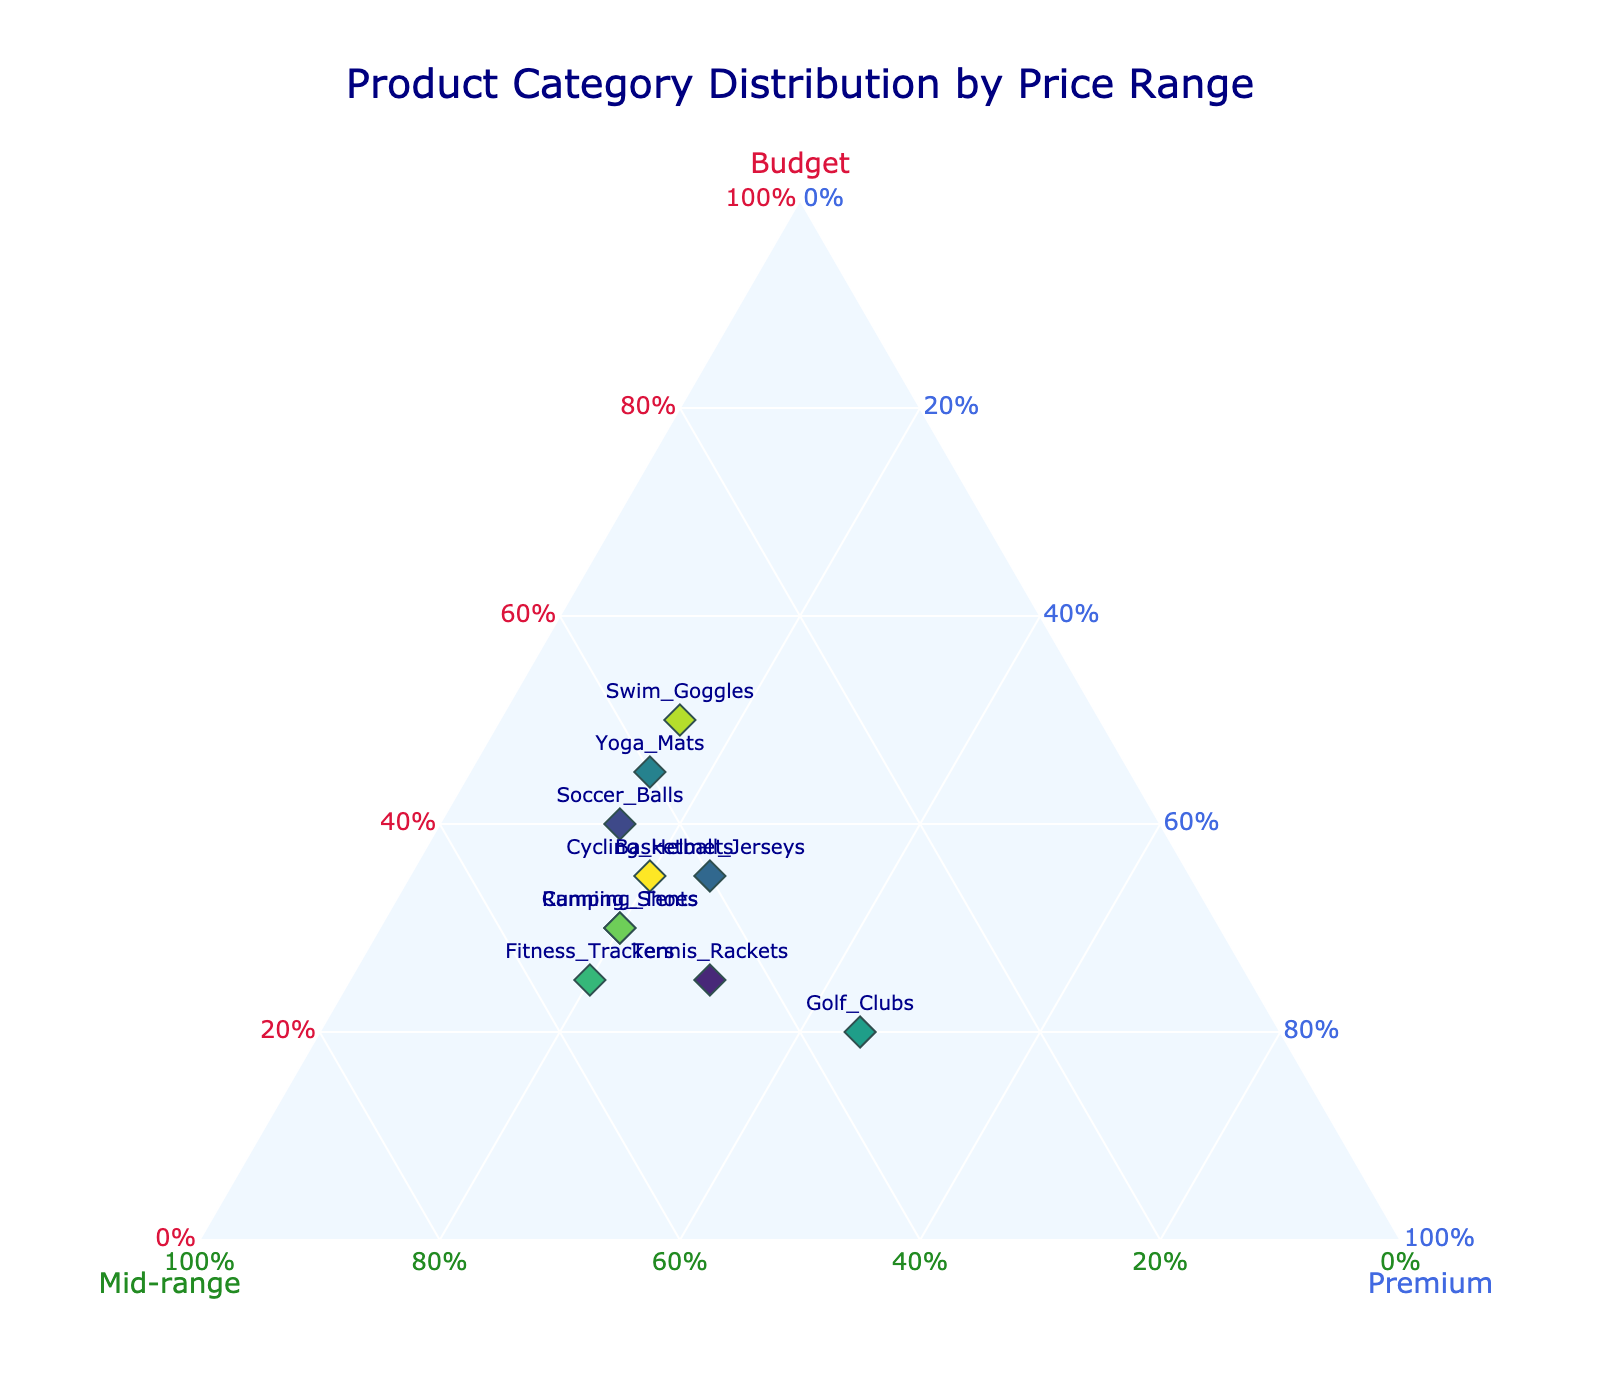What are the three price range categories shown in the plot? The three price range categories shown in the plot are labeled on each axis. They are 'Budget', 'Mid-range', and 'Premium'.
Answer: Budget, Mid-range, Premium How many product categories are displayed in the plot? The plot shows the labels of the product categories as text annotations on the markers. Counting these labels will give the number of product categories.
Answer: 10 Which product category has the highest percentage of Budget products? Locate the marker closest to the 'Budget' axis vertex, which represents the highest percentage of Budget products. The text annotation near this point will indicate the product category.
Answer: Swim Goggles What is the distribution percentage for Budget, Mid-range, and Premium products in Running Shoes? Hover over the marker labeled 'Running Shoes' to see the distribution percentages in the hover text.
Answer: Budget: 30%, Mid-range: 50%, Premium: 20% Compare the percentage of Premium products between Golf Clubs and Soccer Balls. Find the markers corresponding to Golf Clubs and Soccer Balls. Hover over these markers to see the percentage of Premium products in the hover text. Compare the two percentages.
Answer: Golf Clubs: 45%, Soccer Balls: 15% Which product category is evenly balanced between Budget and Mid-range products? Locate the marker closest to the midpoint of the line between the 'Budget' and 'Mid-range' vertices. The text annotation will indicate the product category.
Answer: Basketball Jerseys Calculate the average percentage of Mid-range products among all product categories. Sum the Mid-range percentages of all product categories and divide by the number of categories: (50 + 45 + 45 + 40 + 40 + 35 + 55 + 50 + 35 + 45) / 10 = 44%
Answer: 44% Which product category is closest to having an equal distribution across Budget, Mid-range, and Premium products? Find the marker closest to the center of the ternary plot. Use the text annotation near this point to identify the product category.
Answer: Tennis Rackets Determine the differences in the percentage of Budget products between Yoga Mats and Camping Tents. Hover over the markers for Yoga Mats and Camping Tents. Subtract the percentage of Budget products in Camping Tents from that in Yoga Mats: 45% - 30% = 15%
Answer: 15% Identify the product category with the lowest percentage of Mid-range products. Locate the marker furthest from the 'Mid-range' axis vertex, indicating the lowest percentage for Mid-range products. The text annotation nearby will identify the product category.
Answer: Golf Clubs 